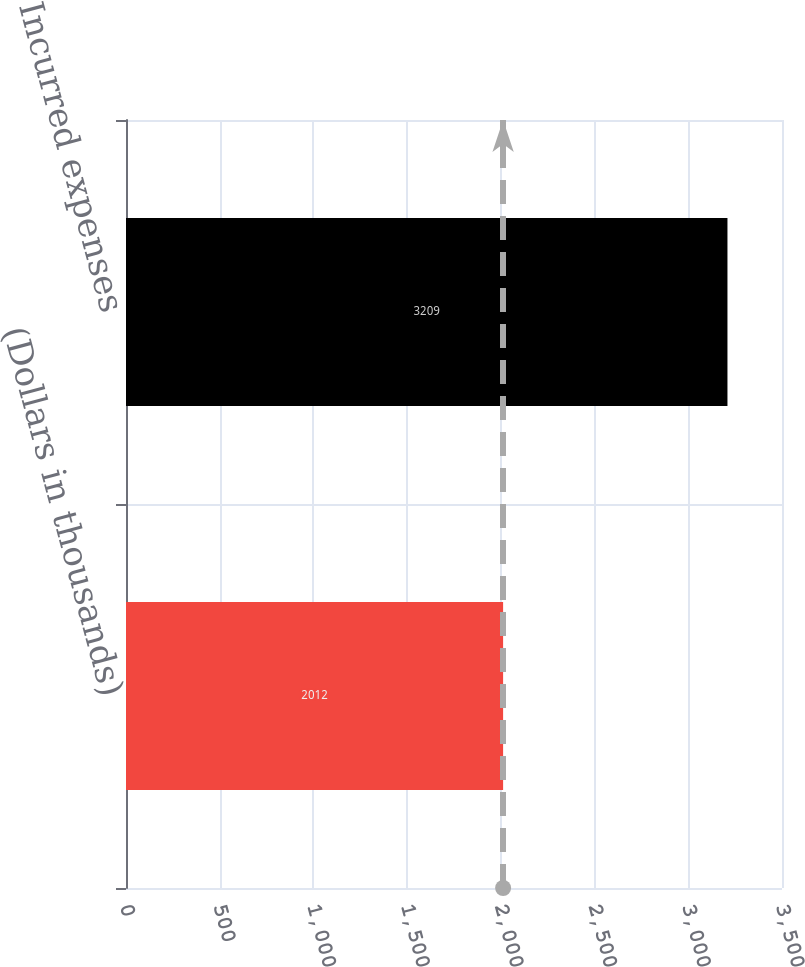Convert chart to OTSL. <chart><loc_0><loc_0><loc_500><loc_500><bar_chart><fcel>(Dollars in thousands)<fcel>Incurred expenses<nl><fcel>2012<fcel>3209<nl></chart> 